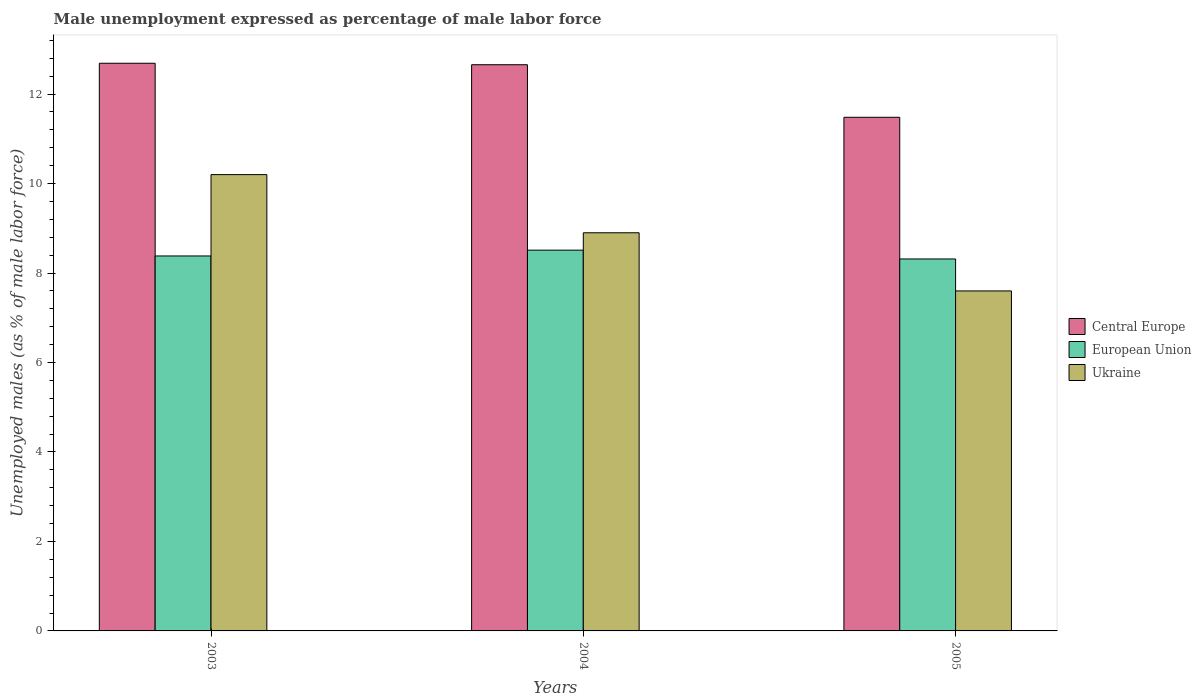What is the label of the 3rd group of bars from the left?
Your answer should be compact. 2005. What is the unemployment in males in in Ukraine in 2003?
Your response must be concise. 10.2. Across all years, what is the maximum unemployment in males in in European Union?
Keep it short and to the point. 8.51. Across all years, what is the minimum unemployment in males in in Central Europe?
Your answer should be compact. 11.48. In which year was the unemployment in males in in Ukraine maximum?
Offer a terse response. 2003. What is the total unemployment in males in in European Union in the graph?
Provide a succinct answer. 25.21. What is the difference between the unemployment in males in in European Union in 2004 and that in 2005?
Keep it short and to the point. 0.2. What is the difference between the unemployment in males in in European Union in 2003 and the unemployment in males in in Central Europe in 2004?
Your answer should be compact. -4.27. What is the average unemployment in males in in Central Europe per year?
Keep it short and to the point. 12.28. In the year 2003, what is the difference between the unemployment in males in in European Union and unemployment in males in in Ukraine?
Offer a very short reply. -1.82. What is the ratio of the unemployment in males in in Central Europe in 2003 to that in 2005?
Your answer should be compact. 1.11. Is the unemployment in males in in Central Europe in 2003 less than that in 2004?
Offer a very short reply. No. What is the difference between the highest and the second highest unemployment in males in in Central Europe?
Offer a very short reply. 0.03. What is the difference between the highest and the lowest unemployment in males in in Central Europe?
Make the answer very short. 1.21. Is the sum of the unemployment in males in in Ukraine in 2003 and 2005 greater than the maximum unemployment in males in in Central Europe across all years?
Provide a short and direct response. Yes. What does the 3rd bar from the right in 2005 represents?
Keep it short and to the point. Central Europe. How many years are there in the graph?
Your answer should be very brief. 3. Are the values on the major ticks of Y-axis written in scientific E-notation?
Your answer should be compact. No. Does the graph contain any zero values?
Offer a very short reply. No. What is the title of the graph?
Your answer should be very brief. Male unemployment expressed as percentage of male labor force. Does "Russian Federation" appear as one of the legend labels in the graph?
Provide a succinct answer. No. What is the label or title of the Y-axis?
Provide a succinct answer. Unemployed males (as % of male labor force). What is the Unemployed males (as % of male labor force) in Central Europe in 2003?
Offer a very short reply. 12.69. What is the Unemployed males (as % of male labor force) in European Union in 2003?
Your response must be concise. 8.38. What is the Unemployed males (as % of male labor force) in Ukraine in 2003?
Keep it short and to the point. 10.2. What is the Unemployed males (as % of male labor force) in Central Europe in 2004?
Provide a succinct answer. 12.66. What is the Unemployed males (as % of male labor force) in European Union in 2004?
Provide a succinct answer. 8.51. What is the Unemployed males (as % of male labor force) in Ukraine in 2004?
Your response must be concise. 8.9. What is the Unemployed males (as % of male labor force) in Central Europe in 2005?
Offer a terse response. 11.48. What is the Unemployed males (as % of male labor force) of European Union in 2005?
Your response must be concise. 8.31. What is the Unemployed males (as % of male labor force) in Ukraine in 2005?
Provide a short and direct response. 7.6. Across all years, what is the maximum Unemployed males (as % of male labor force) of Central Europe?
Offer a terse response. 12.69. Across all years, what is the maximum Unemployed males (as % of male labor force) of European Union?
Your answer should be compact. 8.51. Across all years, what is the maximum Unemployed males (as % of male labor force) of Ukraine?
Make the answer very short. 10.2. Across all years, what is the minimum Unemployed males (as % of male labor force) in Central Europe?
Your response must be concise. 11.48. Across all years, what is the minimum Unemployed males (as % of male labor force) in European Union?
Your answer should be compact. 8.31. Across all years, what is the minimum Unemployed males (as % of male labor force) in Ukraine?
Your response must be concise. 7.6. What is the total Unemployed males (as % of male labor force) in Central Europe in the graph?
Offer a terse response. 36.83. What is the total Unemployed males (as % of male labor force) of European Union in the graph?
Your answer should be compact. 25.21. What is the total Unemployed males (as % of male labor force) in Ukraine in the graph?
Give a very brief answer. 26.7. What is the difference between the Unemployed males (as % of male labor force) in Central Europe in 2003 and that in 2004?
Offer a very short reply. 0.03. What is the difference between the Unemployed males (as % of male labor force) of European Union in 2003 and that in 2004?
Give a very brief answer. -0.13. What is the difference between the Unemployed males (as % of male labor force) in Central Europe in 2003 and that in 2005?
Make the answer very short. 1.21. What is the difference between the Unemployed males (as % of male labor force) of European Union in 2003 and that in 2005?
Provide a succinct answer. 0.07. What is the difference between the Unemployed males (as % of male labor force) of Central Europe in 2004 and that in 2005?
Give a very brief answer. 1.17. What is the difference between the Unemployed males (as % of male labor force) in European Union in 2004 and that in 2005?
Offer a very short reply. 0.2. What is the difference between the Unemployed males (as % of male labor force) in Central Europe in 2003 and the Unemployed males (as % of male labor force) in European Union in 2004?
Your answer should be very brief. 4.18. What is the difference between the Unemployed males (as % of male labor force) of Central Europe in 2003 and the Unemployed males (as % of male labor force) of Ukraine in 2004?
Give a very brief answer. 3.79. What is the difference between the Unemployed males (as % of male labor force) of European Union in 2003 and the Unemployed males (as % of male labor force) of Ukraine in 2004?
Offer a terse response. -0.52. What is the difference between the Unemployed males (as % of male labor force) of Central Europe in 2003 and the Unemployed males (as % of male labor force) of European Union in 2005?
Your response must be concise. 4.37. What is the difference between the Unemployed males (as % of male labor force) in Central Europe in 2003 and the Unemployed males (as % of male labor force) in Ukraine in 2005?
Give a very brief answer. 5.09. What is the difference between the Unemployed males (as % of male labor force) in European Union in 2003 and the Unemployed males (as % of male labor force) in Ukraine in 2005?
Your answer should be compact. 0.78. What is the difference between the Unemployed males (as % of male labor force) of Central Europe in 2004 and the Unemployed males (as % of male labor force) of European Union in 2005?
Ensure brevity in your answer.  4.34. What is the difference between the Unemployed males (as % of male labor force) of Central Europe in 2004 and the Unemployed males (as % of male labor force) of Ukraine in 2005?
Ensure brevity in your answer.  5.06. What is the difference between the Unemployed males (as % of male labor force) in European Union in 2004 and the Unemployed males (as % of male labor force) in Ukraine in 2005?
Your answer should be very brief. 0.91. What is the average Unemployed males (as % of male labor force) of Central Europe per year?
Keep it short and to the point. 12.28. What is the average Unemployed males (as % of male labor force) of European Union per year?
Provide a short and direct response. 8.4. In the year 2003, what is the difference between the Unemployed males (as % of male labor force) of Central Europe and Unemployed males (as % of male labor force) of European Union?
Give a very brief answer. 4.31. In the year 2003, what is the difference between the Unemployed males (as % of male labor force) of Central Europe and Unemployed males (as % of male labor force) of Ukraine?
Your answer should be very brief. 2.49. In the year 2003, what is the difference between the Unemployed males (as % of male labor force) of European Union and Unemployed males (as % of male labor force) of Ukraine?
Provide a short and direct response. -1.82. In the year 2004, what is the difference between the Unemployed males (as % of male labor force) in Central Europe and Unemployed males (as % of male labor force) in European Union?
Provide a short and direct response. 4.14. In the year 2004, what is the difference between the Unemployed males (as % of male labor force) in Central Europe and Unemployed males (as % of male labor force) in Ukraine?
Give a very brief answer. 3.76. In the year 2004, what is the difference between the Unemployed males (as % of male labor force) of European Union and Unemployed males (as % of male labor force) of Ukraine?
Provide a succinct answer. -0.39. In the year 2005, what is the difference between the Unemployed males (as % of male labor force) of Central Europe and Unemployed males (as % of male labor force) of European Union?
Your response must be concise. 3.17. In the year 2005, what is the difference between the Unemployed males (as % of male labor force) of Central Europe and Unemployed males (as % of male labor force) of Ukraine?
Give a very brief answer. 3.88. In the year 2005, what is the difference between the Unemployed males (as % of male labor force) of European Union and Unemployed males (as % of male labor force) of Ukraine?
Provide a short and direct response. 0.71. What is the ratio of the Unemployed males (as % of male labor force) of European Union in 2003 to that in 2004?
Provide a succinct answer. 0.98. What is the ratio of the Unemployed males (as % of male labor force) in Ukraine in 2003 to that in 2004?
Ensure brevity in your answer.  1.15. What is the ratio of the Unemployed males (as % of male labor force) of Central Europe in 2003 to that in 2005?
Your answer should be very brief. 1.11. What is the ratio of the Unemployed males (as % of male labor force) in Ukraine in 2003 to that in 2005?
Give a very brief answer. 1.34. What is the ratio of the Unemployed males (as % of male labor force) of Central Europe in 2004 to that in 2005?
Ensure brevity in your answer.  1.1. What is the ratio of the Unemployed males (as % of male labor force) in European Union in 2004 to that in 2005?
Your answer should be compact. 1.02. What is the ratio of the Unemployed males (as % of male labor force) in Ukraine in 2004 to that in 2005?
Your answer should be very brief. 1.17. What is the difference between the highest and the second highest Unemployed males (as % of male labor force) in Central Europe?
Offer a terse response. 0.03. What is the difference between the highest and the second highest Unemployed males (as % of male labor force) in European Union?
Provide a short and direct response. 0.13. What is the difference between the highest and the lowest Unemployed males (as % of male labor force) in Central Europe?
Offer a terse response. 1.21. What is the difference between the highest and the lowest Unemployed males (as % of male labor force) in European Union?
Give a very brief answer. 0.2. What is the difference between the highest and the lowest Unemployed males (as % of male labor force) of Ukraine?
Provide a succinct answer. 2.6. 